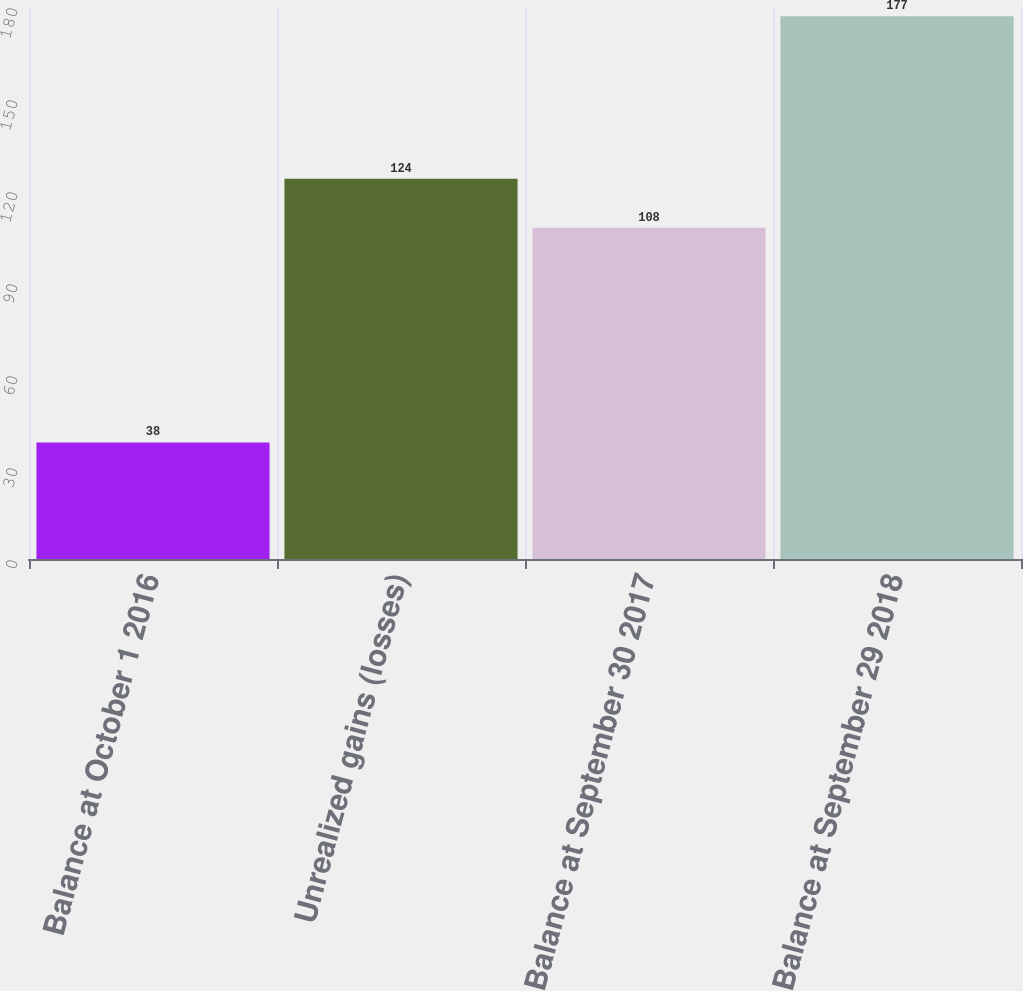Convert chart to OTSL. <chart><loc_0><loc_0><loc_500><loc_500><bar_chart><fcel>Balance at October 1 2016<fcel>Unrealized gains (losses)<fcel>Balance at September 30 2017<fcel>Balance at September 29 2018<nl><fcel>38<fcel>124<fcel>108<fcel>177<nl></chart> 